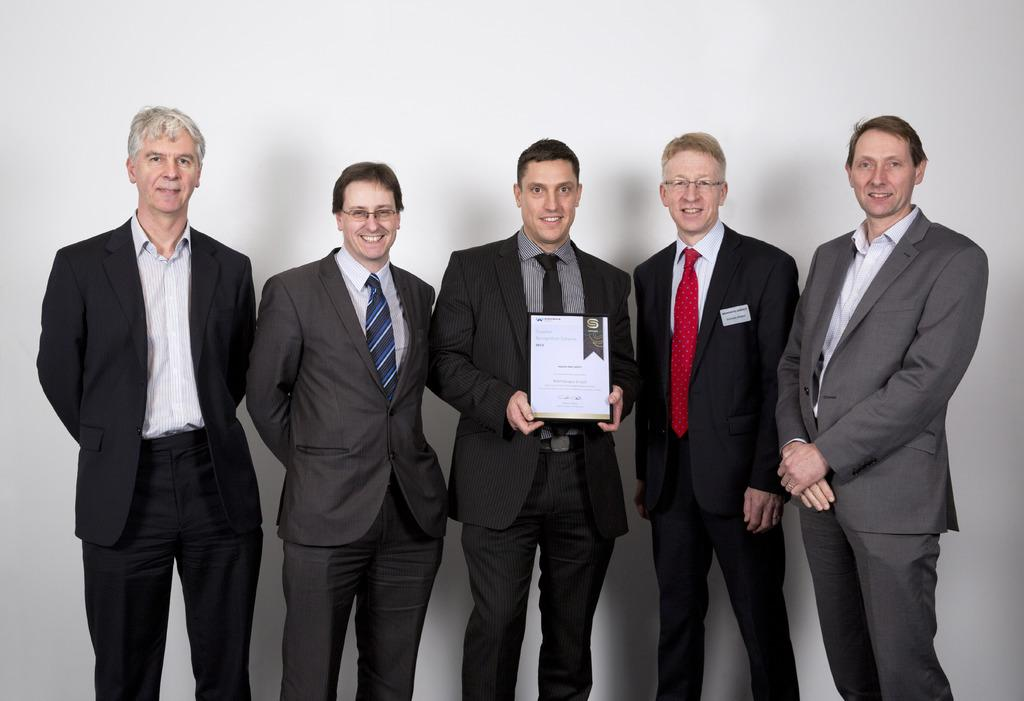How many people are in the image? There are people in the image, but the exact number is not specified. What are the people doing in the image? The people are standing and smiling in the image. Can you describe the object being held by one of the people? One person is holding an object, but its description is not provided. What can be seen in the background of the image? There is a wall in the background of the image. Can you tell me how many robins are perched on the wall in the image? There are no robins present in the image; it only features people standing and smiling. Is the park visible in the image? The facts do not mention a park, so it is not possible to determine if it is visible in the image. 